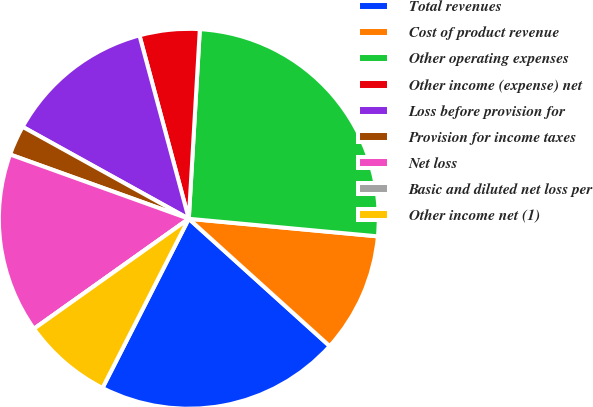Convert chart. <chart><loc_0><loc_0><loc_500><loc_500><pie_chart><fcel>Total revenues<fcel>Cost of product revenue<fcel>Other operating expenses<fcel>Other income (expense) net<fcel>Loss before provision for<fcel>Provision for income taxes<fcel>Net loss<fcel>Basic and diluted net loss per<fcel>Other income net (1)<nl><fcel>20.81%<fcel>10.22%<fcel>25.55%<fcel>5.11%<fcel>12.77%<fcel>2.55%<fcel>15.33%<fcel>0.0%<fcel>7.66%<nl></chart> 